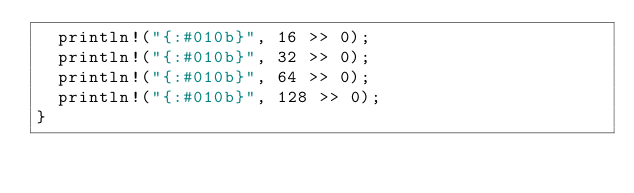Convert code to text. <code><loc_0><loc_0><loc_500><loc_500><_Rust_>  println!("{:#010b}", 16 >> 0);
  println!("{:#010b}", 32 >> 0);
  println!("{:#010b}", 64 >> 0);
  println!("{:#010b}", 128 >> 0);
}
</code> 